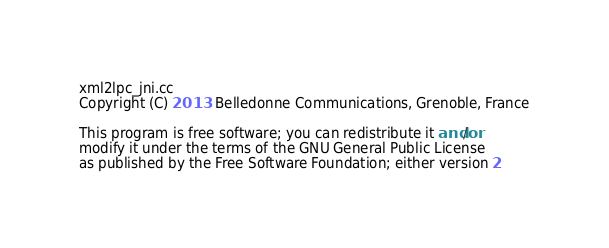<code> <loc_0><loc_0><loc_500><loc_500><_C++_>xml2lpc_jni.cc
Copyright (C) 2013  Belledonne Communications, Grenoble, France

This program is free software; you can redistribute it and/or
modify it under the terms of the GNU General Public License
as published by the Free Software Foundation; either version 2</code> 